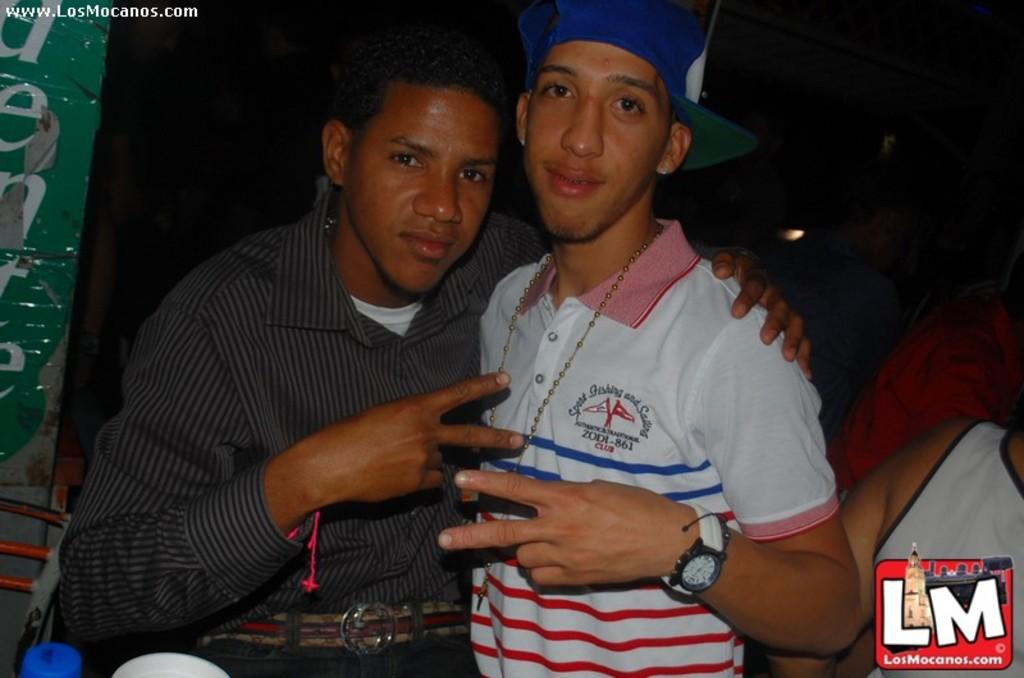<image>
Summarize the visual content of the image. Two guys pose for a picture together, brought to you by www.LosMocanos.com. 